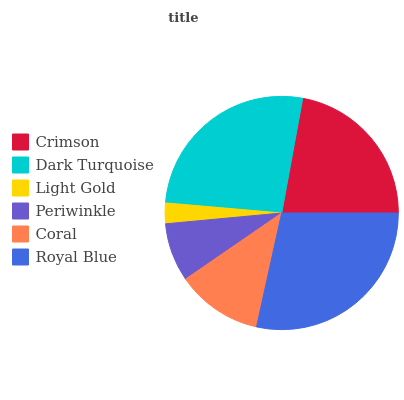Is Light Gold the minimum?
Answer yes or no. Yes. Is Royal Blue the maximum?
Answer yes or no. Yes. Is Dark Turquoise the minimum?
Answer yes or no. No. Is Dark Turquoise the maximum?
Answer yes or no. No. Is Dark Turquoise greater than Crimson?
Answer yes or no. Yes. Is Crimson less than Dark Turquoise?
Answer yes or no. Yes. Is Crimson greater than Dark Turquoise?
Answer yes or no. No. Is Dark Turquoise less than Crimson?
Answer yes or no. No. Is Crimson the high median?
Answer yes or no. Yes. Is Coral the low median?
Answer yes or no. Yes. Is Periwinkle the high median?
Answer yes or no. No. Is Periwinkle the low median?
Answer yes or no. No. 